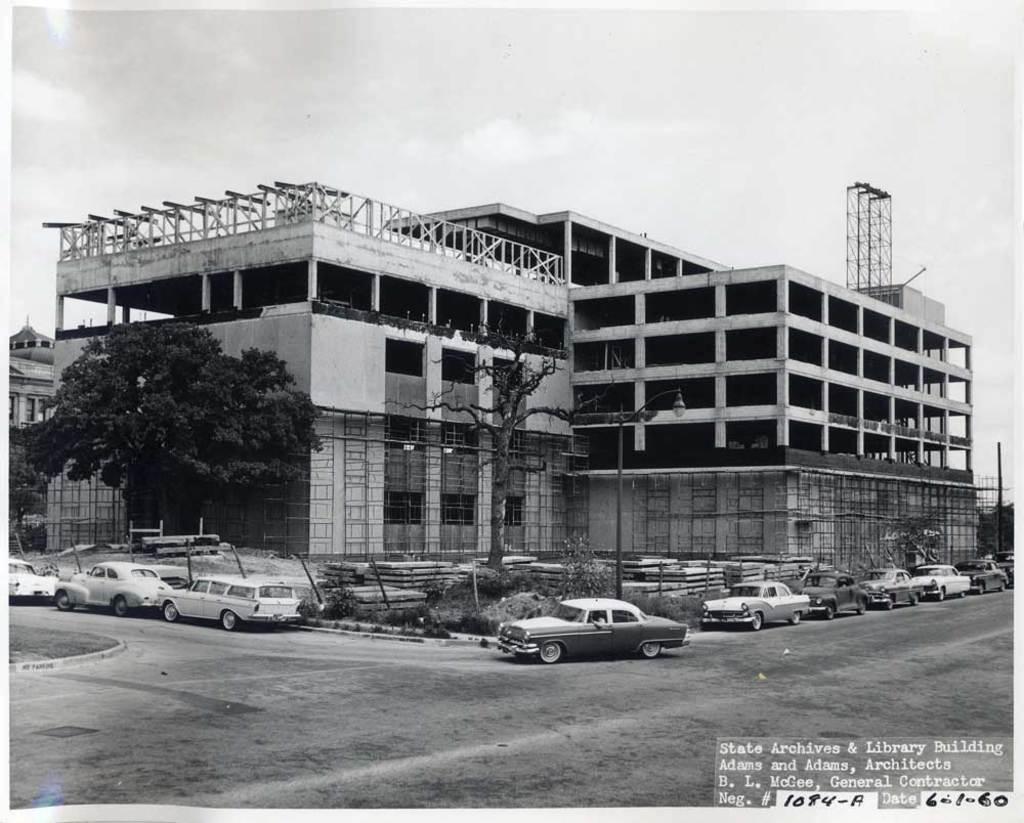How would you summarize this image in a sentence or two? In the given picture, i can see a building. Top of the building a metal an iron metal and this building looks like a incomplete after that few trees and cars which is parked on. After that i can see electrical pole which includes light and i can see a sky, Towards left we can see a building and finally we can see a road. 